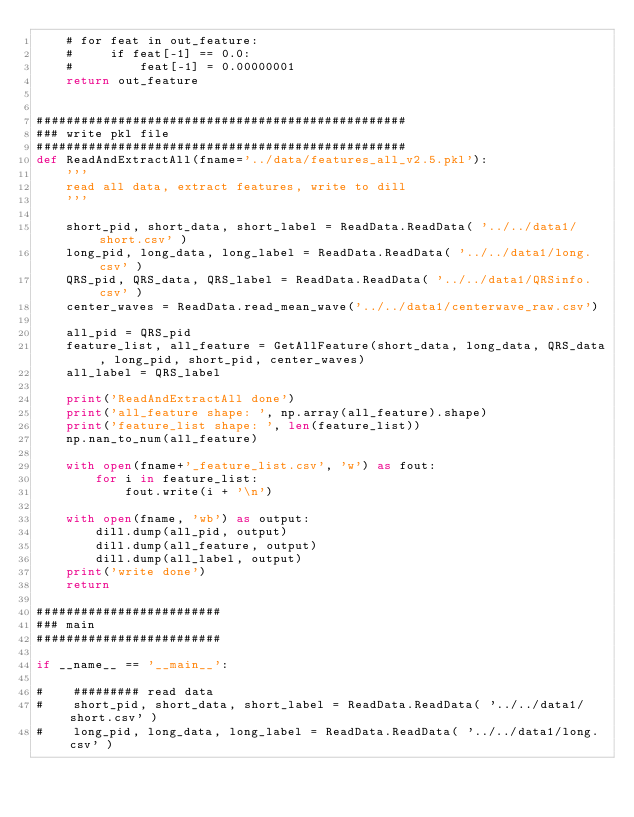<code> <loc_0><loc_0><loc_500><loc_500><_Python_>    # for feat in out_feature:
    #     if feat[-1] == 0.0:
    #         feat[-1] = 0.00000001
    return out_feature


##################################################
### write pkl file
##################################################
def ReadAndExtractAll(fname='../data/features_all_v2.5.pkl'):
    '''
    read all data, extract features, write to dill
    '''
    
    short_pid, short_data, short_label = ReadData.ReadData( '../../data1/short.csv' )
    long_pid, long_data, long_label = ReadData.ReadData( '../../data1/long.csv' )
    QRS_pid, QRS_data, QRS_label = ReadData.ReadData( '../../data1/QRSinfo.csv' )
    center_waves = ReadData.read_mean_wave('../../data1/centerwave_raw.csv')
    
    all_pid = QRS_pid
    feature_list, all_feature = GetAllFeature(short_data, long_data, QRS_data, long_pid, short_pid, center_waves)
    all_label = QRS_label
    
    print('ReadAndExtractAll done')
    print('all_feature shape: ', np.array(all_feature).shape)
    print('feature_list shape: ', len(feature_list))
    np.nan_to_num(all_feature)
    
    with open(fname+'_feature_list.csv', 'w') as fout:
        for i in feature_list:
            fout.write(i + '\n')
    
    with open(fname, 'wb') as output:
        dill.dump(all_pid, output)
        dill.dump(all_feature, output)
        dill.dump(all_label, output)
    print('write done')
    return

#########################
### main
#########################

if __name__ == '__main__':    

#    ######### read data
#    short_pid, short_data, short_label = ReadData.ReadData( '../../data1/short.csv' )
#    long_pid, long_data, long_label = ReadData.ReadData( '../../data1/long.csv' )</code> 